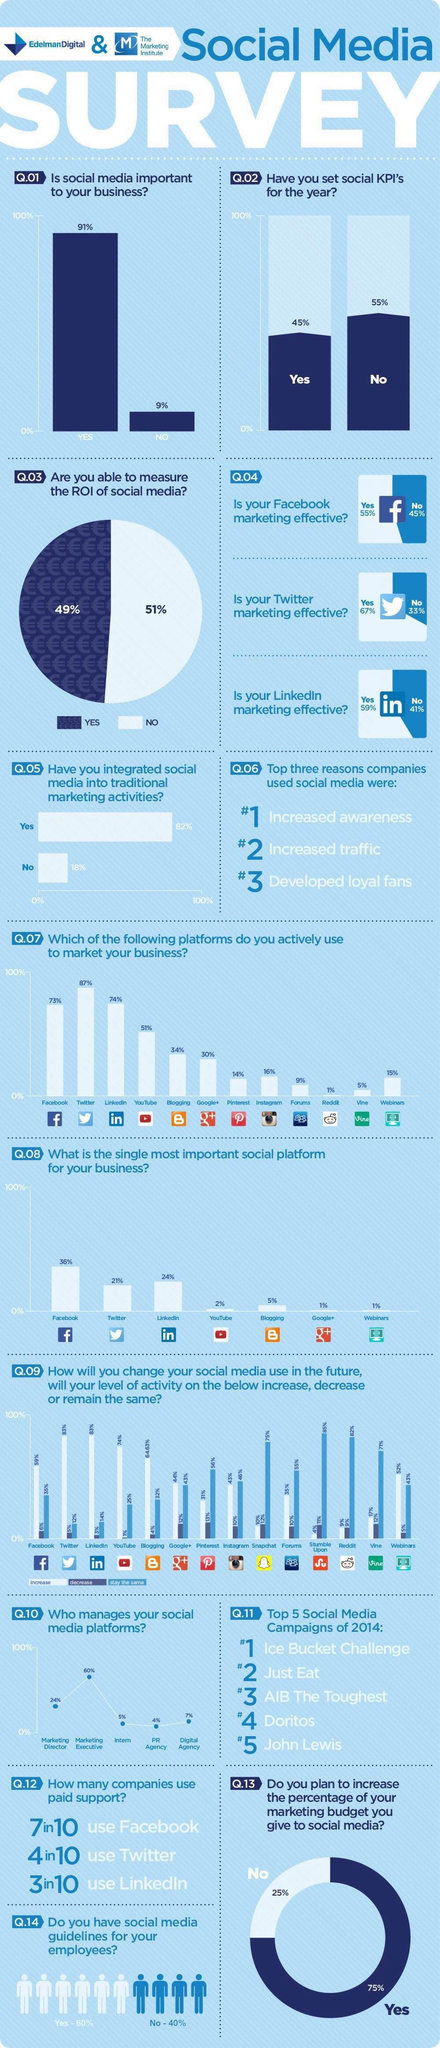For how many users their level of activity in YouTube remains the same?
Answer the question with a short phrase. 25% How much is the level of activity increase for Facebook? 59% How much is the level of activity decrease for Blogging? 4% Which platform is the second best to use in order to market your business? LinkedIn For how many users their level of  activity in Facebook remains the same? 35% How much is the level of activity increase for Pinterest? 31% How many social media platforms have active business users less than 30% as given in the bar chart? 6 How much is the level of activity decrease for Facebook? 6% How much is the level of activity increase for YouTube? 74% How much is the level of activity increase for LinkedIn? 83% 